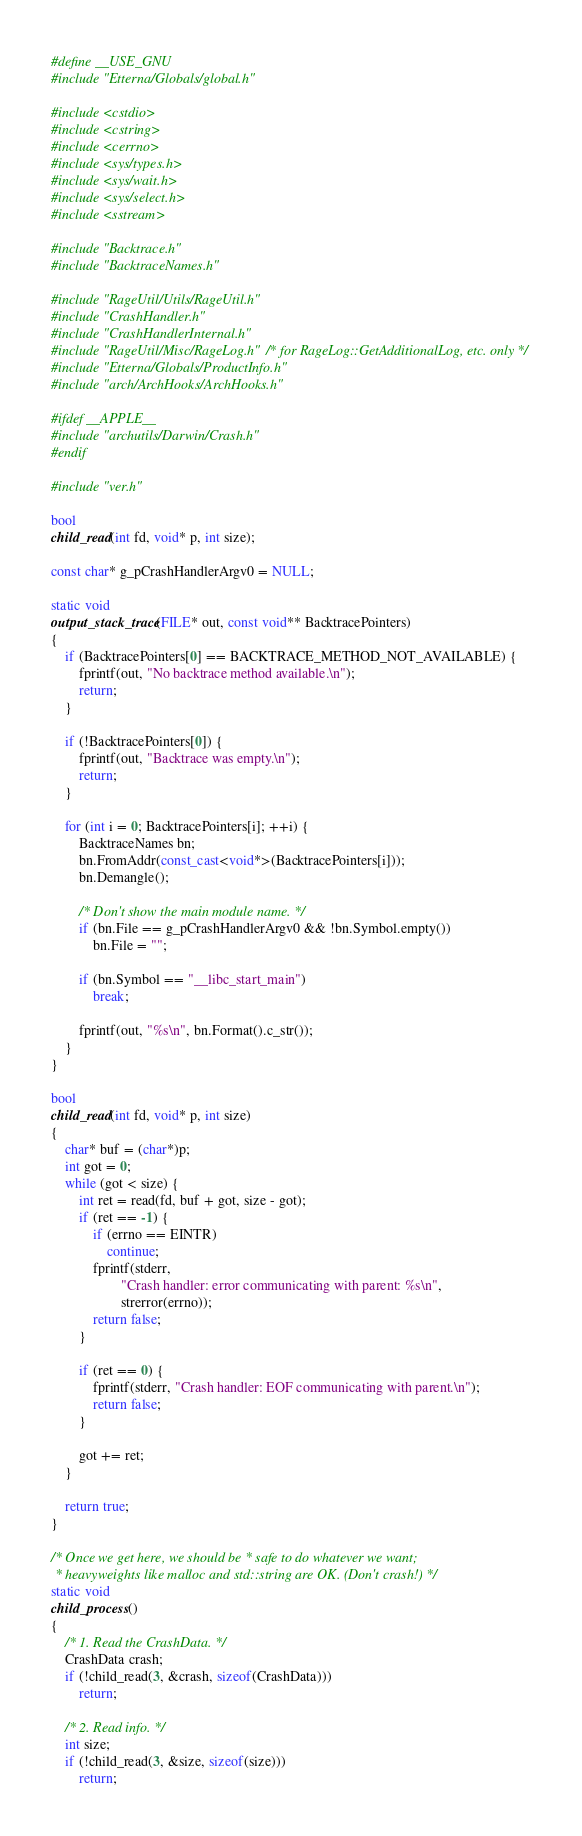Convert code to text. <code><loc_0><loc_0><loc_500><loc_500><_C++_>#define __USE_GNU
#include "Etterna/Globals/global.h"

#include <cstdio>
#include <cstring>
#include <cerrno>
#include <sys/types.h>
#include <sys/wait.h>
#include <sys/select.h>
#include <sstream>

#include "Backtrace.h"
#include "BacktraceNames.h"

#include "RageUtil/Utils/RageUtil.h"
#include "CrashHandler.h"
#include "CrashHandlerInternal.h"
#include "RageUtil/Misc/RageLog.h" /* for RageLog::GetAdditionalLog, etc. only */
#include "Etterna/Globals/ProductInfo.h"
#include "arch/ArchHooks/ArchHooks.h"

#ifdef __APPLE__
#include "archutils/Darwin/Crash.h"
#endif

#include "ver.h"

bool
child_read(int fd, void* p, int size);

const char* g_pCrashHandlerArgv0 = NULL;

static void
output_stack_trace(FILE* out, const void** BacktracePointers)
{
	if (BacktracePointers[0] == BACKTRACE_METHOD_NOT_AVAILABLE) {
		fprintf(out, "No backtrace method available.\n");
		return;
	}

	if (!BacktracePointers[0]) {
		fprintf(out, "Backtrace was empty.\n");
		return;
	}

	for (int i = 0; BacktracePointers[i]; ++i) {
		BacktraceNames bn;
		bn.FromAddr(const_cast<void*>(BacktracePointers[i]));
		bn.Demangle();

		/* Don't show the main module name. */
		if (bn.File == g_pCrashHandlerArgv0 && !bn.Symbol.empty())
			bn.File = "";

		if (bn.Symbol == "__libc_start_main")
			break;

		fprintf(out, "%s\n", bn.Format().c_str());
	}
}

bool
child_read(int fd, void* p, int size)
{
	char* buf = (char*)p;
	int got = 0;
	while (got < size) {
		int ret = read(fd, buf + got, size - got);
		if (ret == -1) {
			if (errno == EINTR)
				continue;
			fprintf(stderr,
					"Crash handler: error communicating with parent: %s\n",
					strerror(errno));
			return false;
		}

		if (ret == 0) {
			fprintf(stderr, "Crash handler: EOF communicating with parent.\n");
			return false;
		}

		got += ret;
	}

	return true;
}

/* Once we get here, we should be * safe to do whatever we want;
 * heavyweights like malloc and std::string are OK. (Don't crash!) */
static void
child_process()
{
	/* 1. Read the CrashData. */
	CrashData crash;
	if (!child_read(3, &crash, sizeof(CrashData)))
		return;

	/* 2. Read info. */
	int size;
	if (!child_read(3, &size, sizeof(size)))
		return;</code> 